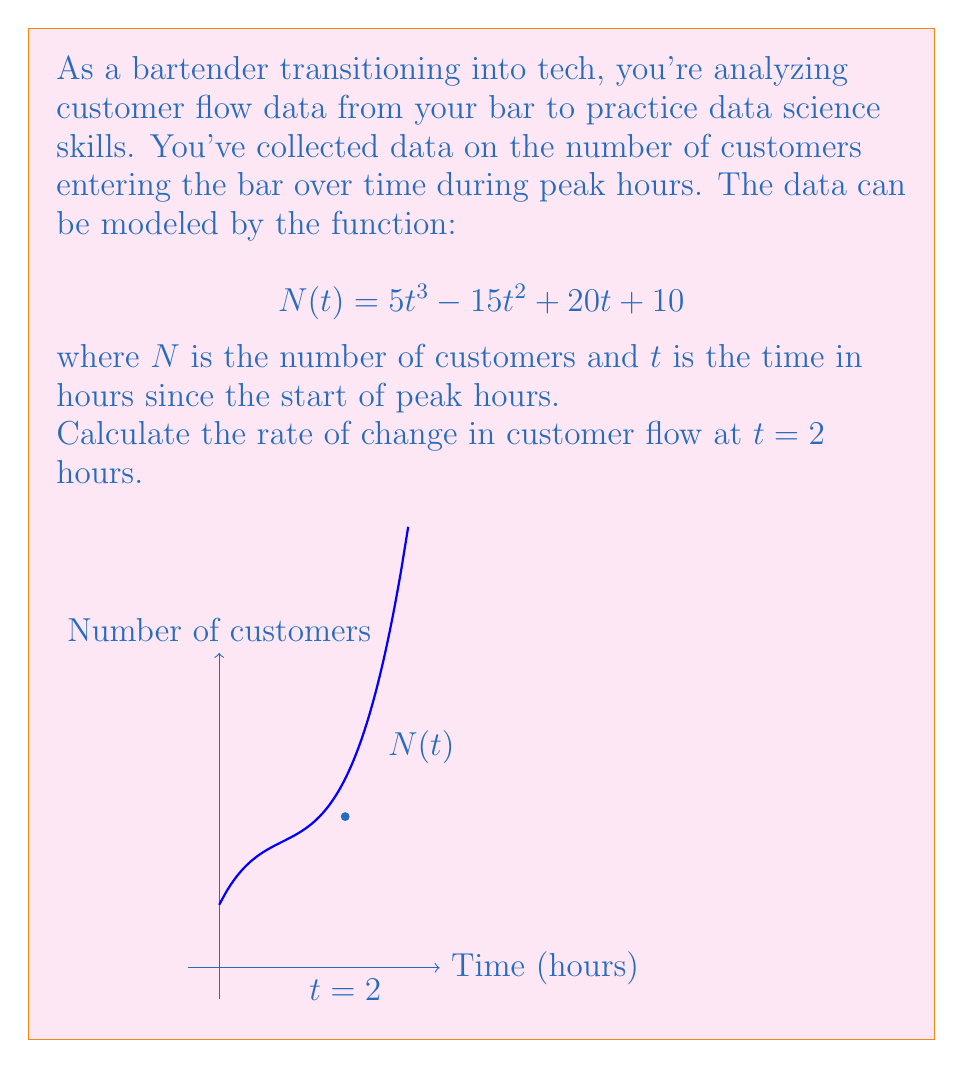Give your solution to this math problem. To find the rate of change in customer flow at $t = 2$ hours, we need to calculate the derivative of $N(t)$ and evaluate it at $t = 2$. Here's the step-by-step process:

1) First, let's find the derivative of $N(t)$:
   $$N(t) = 5t^3 - 15t^2 + 20t + 10$$
   $$N'(t) = 15t^2 - 30t + 20$$

2) Now, we evaluate $N'(t)$ at $t = 2$:
   $$N'(2) = 15(2)^2 - 30(2) + 20$$
   
3) Let's calculate this step by step:
   $$N'(2) = 15(4) - 60 + 20$$
   $$N'(2) = 60 - 60 + 20$$
   $$N'(2) = 20$$

4) Interpret the result: At $t = 2$ hours, the rate of change in customer flow is 20 customers per hour.
Answer: 20 customers/hour 